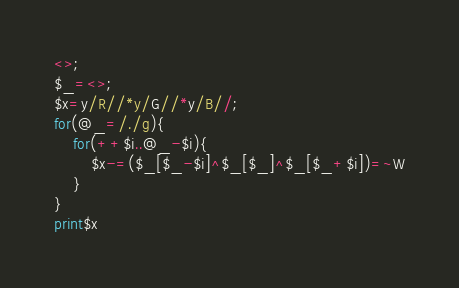<code> <loc_0><loc_0><loc_500><loc_500><_Perl_><>;
$_=<>;
$x=y/R//*y/G//*y/B//;
for(@_=/./g){
	for(++$i..@_-$i){
		$x-=($_[$_-$i]^$_[$_]^$_[$_+$i])=~W
	}
}
print$x
</code> 